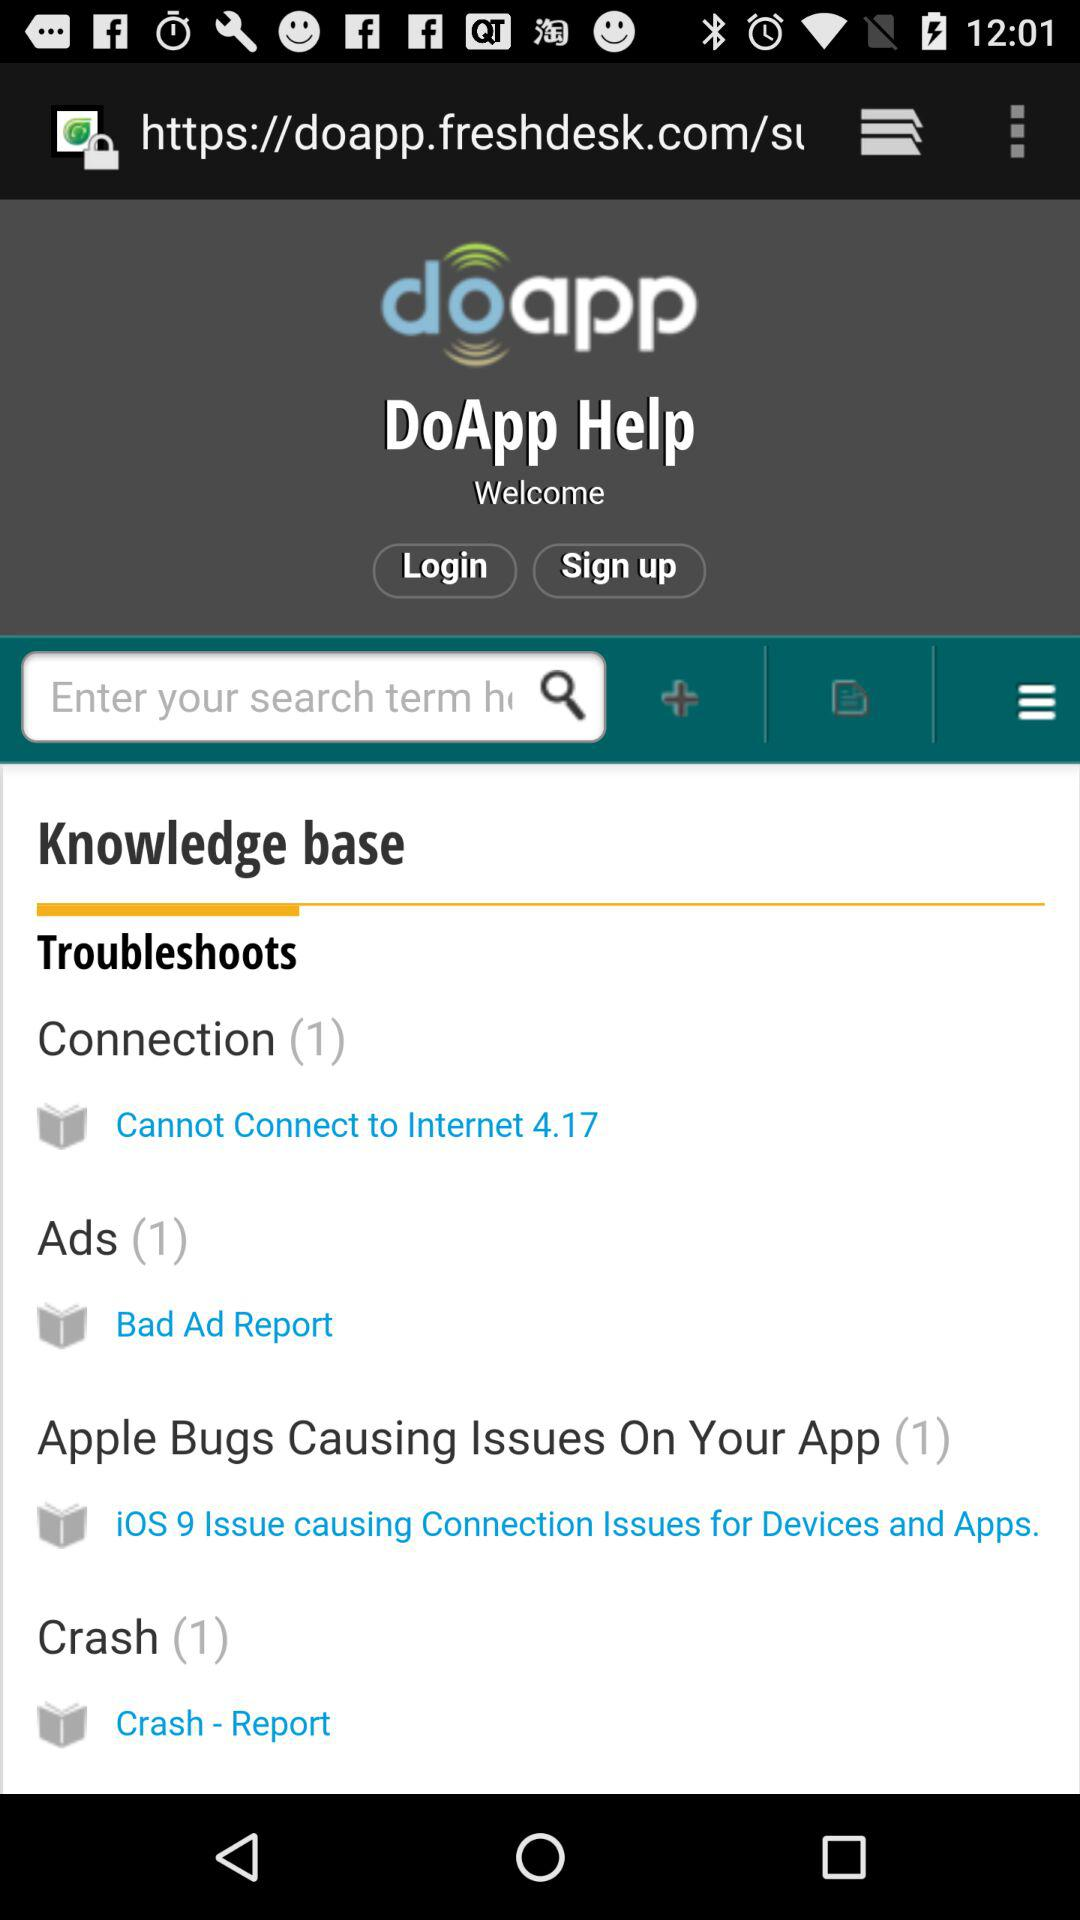What is entered into the search bar?
When the provided information is insufficient, respond with <no answer>. <no answer> 